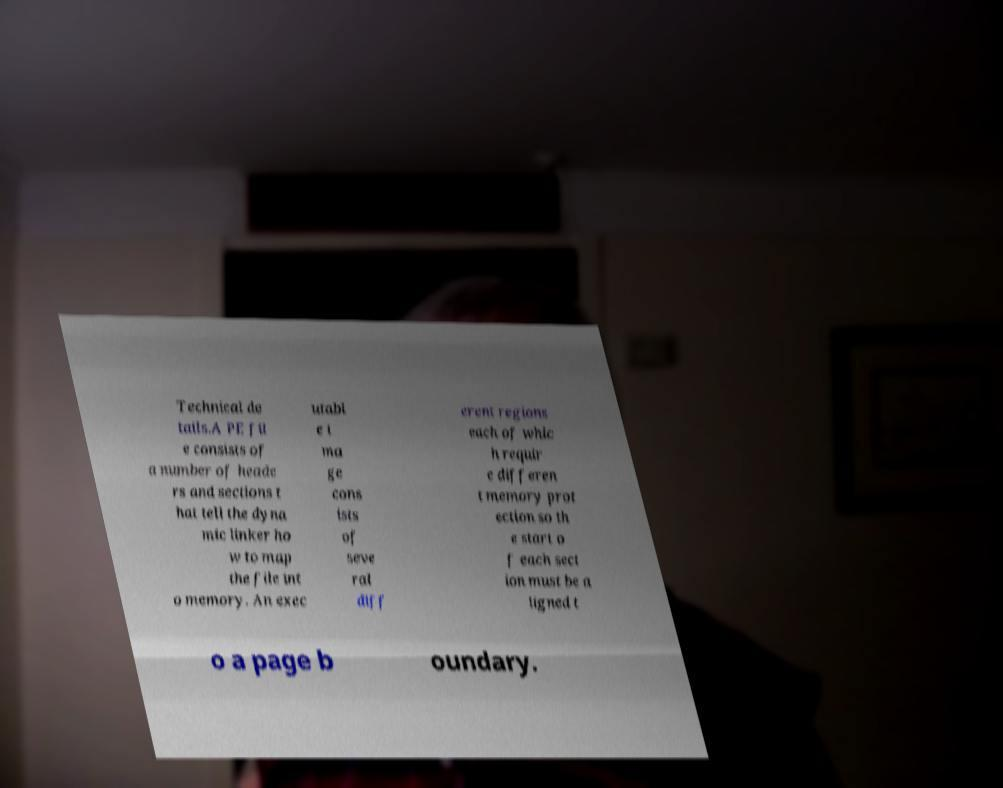Can you read and provide the text displayed in the image?This photo seems to have some interesting text. Can you extract and type it out for me? Technical de tails.A PE fil e consists of a number of heade rs and sections t hat tell the dyna mic linker ho w to map the file int o memory. An exec utabl e i ma ge cons ists of seve ral diff erent regions each of whic h requir e differen t memory prot ection so th e start o f each sect ion must be a ligned t o a page b oundary. 